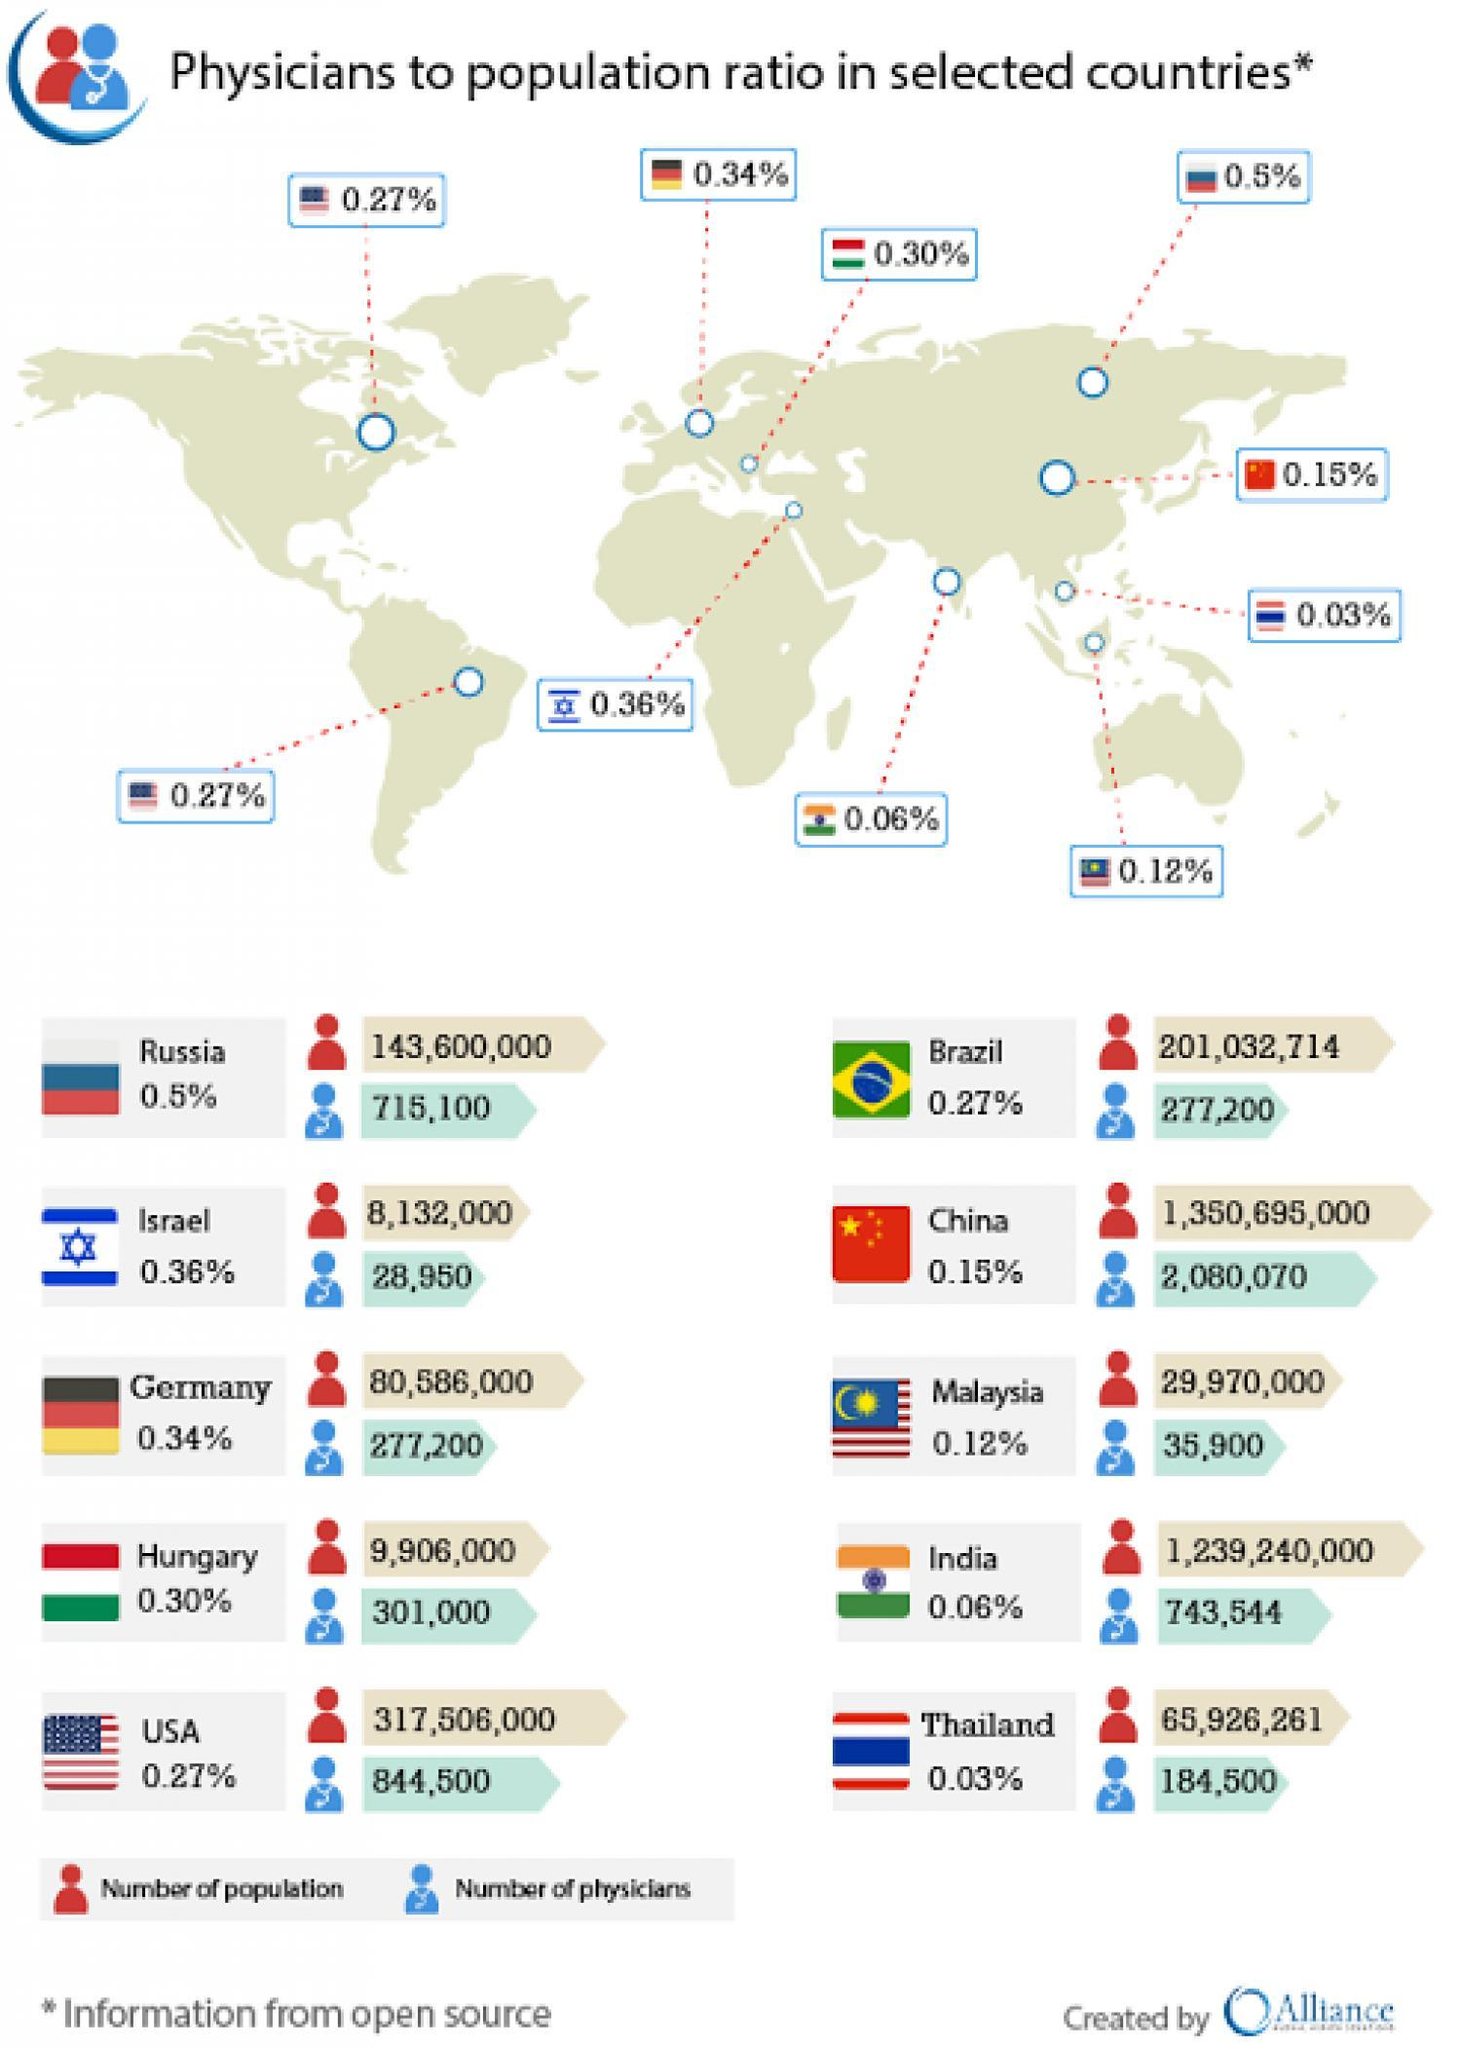What is the physician to population ratio of Russia and Israel, taken together?
Answer the question with a short phrase. 0.86% What is the physician to population ratio of Brazil and China, taken together? 0.42% 